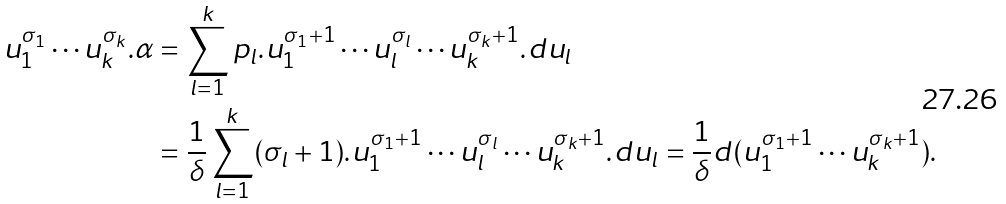Convert formula to latex. <formula><loc_0><loc_0><loc_500><loc_500>u _ { 1 } ^ { \sigma _ { 1 } } \cdots u _ { k } ^ { \sigma _ { k } } . \alpha & = \sum _ { l = 1 } ^ { k } p _ { l } . u _ { 1 } ^ { \sigma _ { 1 } + 1 } \cdots u _ { l } ^ { \sigma _ { l } } \cdots u _ { k } ^ { \sigma _ { k } + 1 } . d u _ { l } \\ \quad & = \frac { 1 } { \delta } \sum _ { l = 1 } ^ { k } ( \sigma _ { l } + 1 ) . u _ { 1 } ^ { \sigma _ { 1 } + 1 } \cdots u _ { l } ^ { \sigma _ { l } } \cdots u _ { k } ^ { \sigma _ { k } + 1 } . d u _ { l } = \frac { 1 } { \delta } d ( u _ { 1 } ^ { \sigma _ { 1 } + 1 } \cdots u _ { k } ^ { \sigma _ { k } + 1 } ) .</formula> 